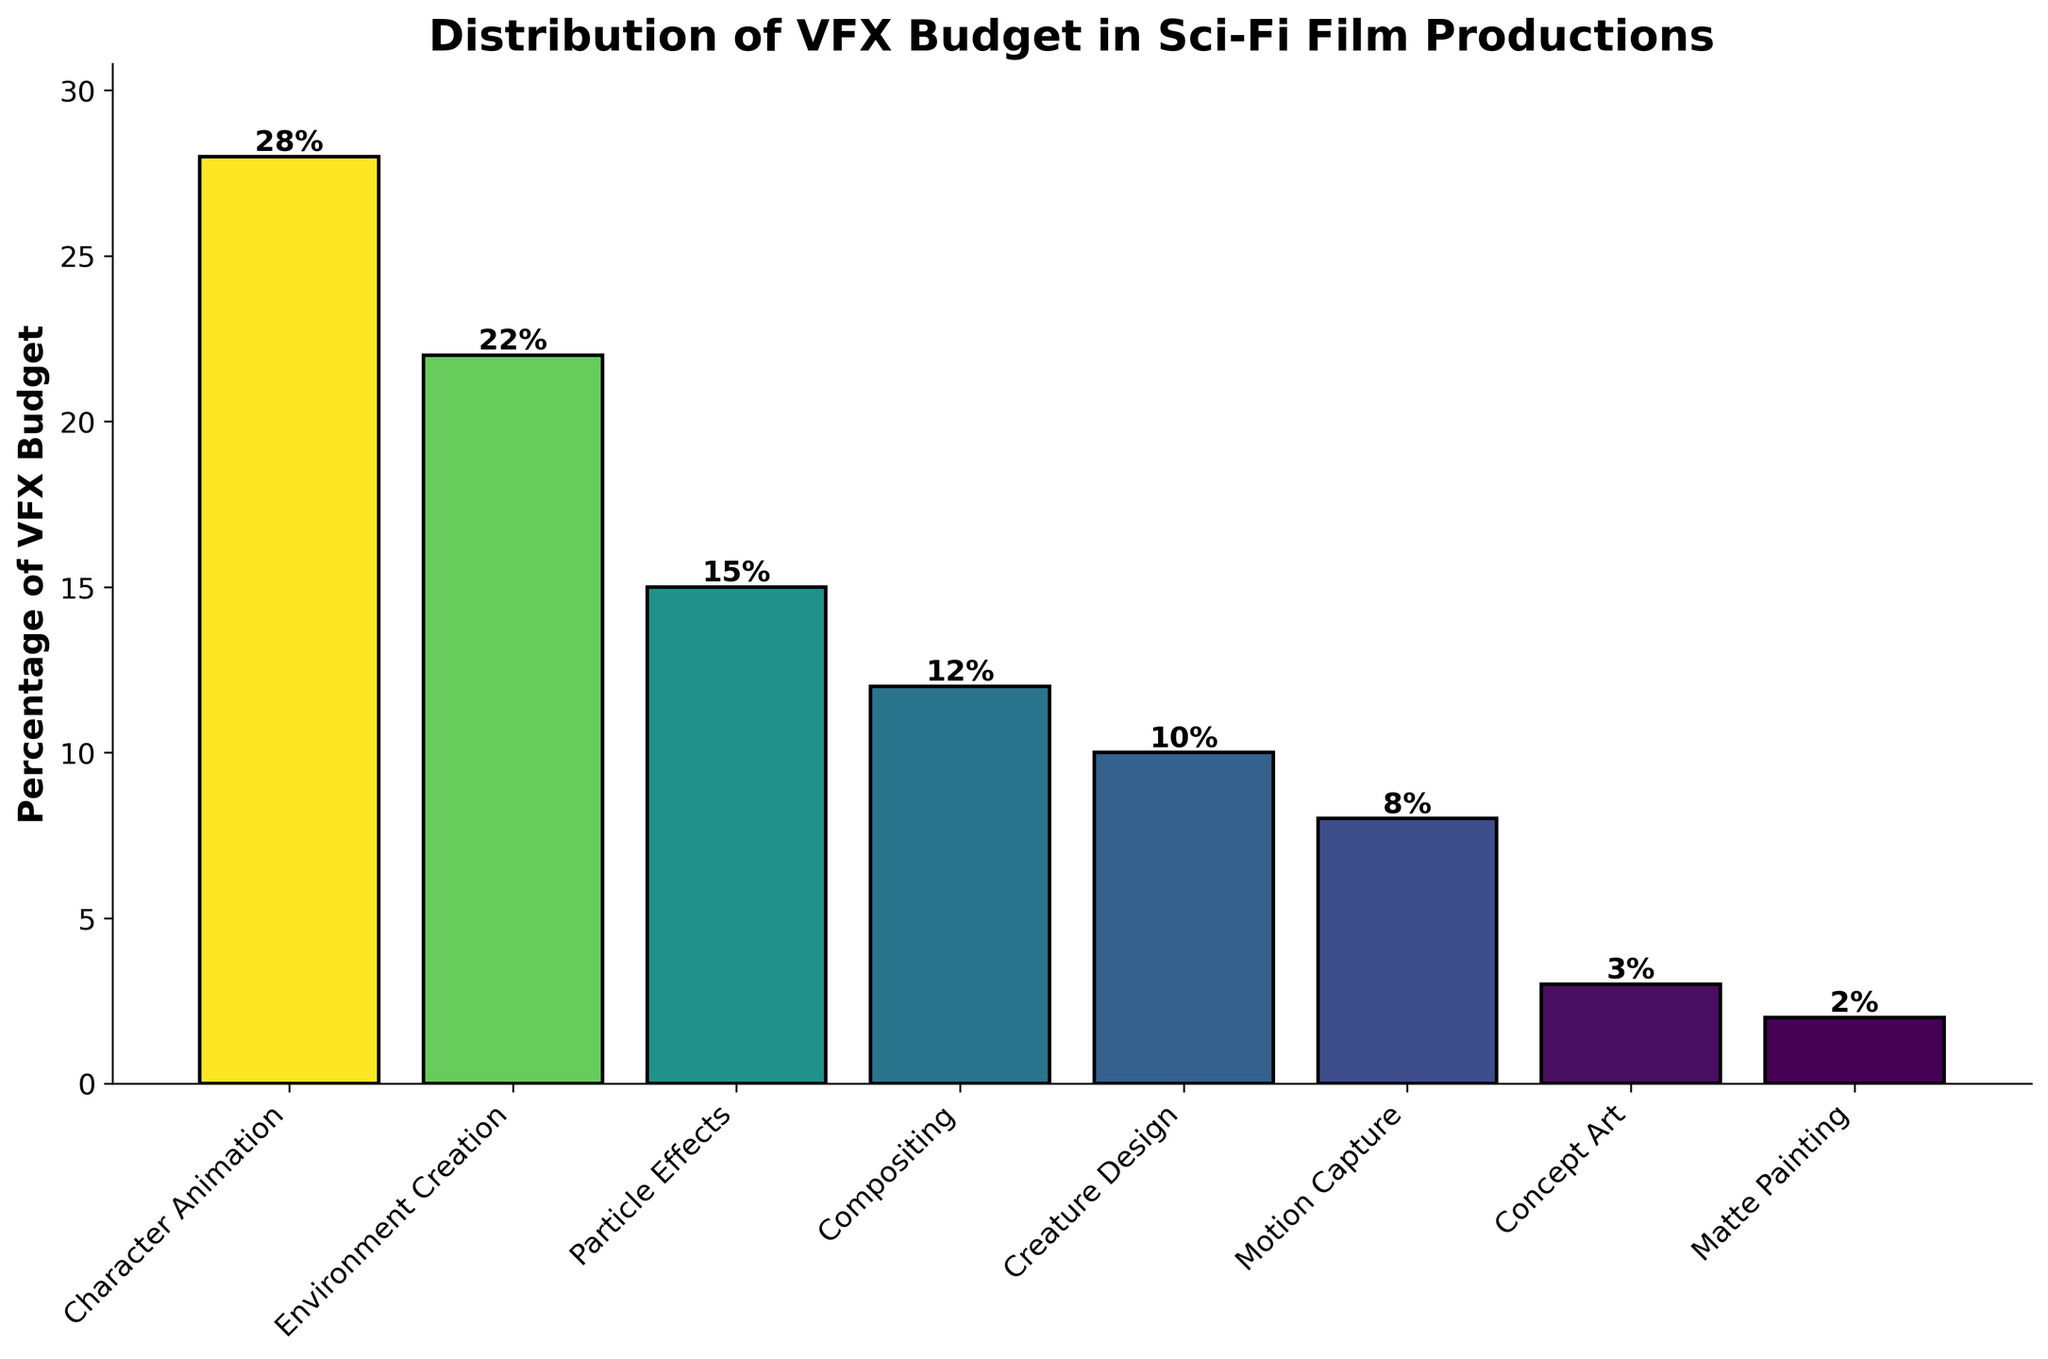Which department has the highest percentage of the VFX budget? The department with the highest bar represents the highest percentage. In the chart, the tallest bar corresponds to "Character Animation" with 28%.
Answer: Character Animation What is the combined percentage of the budget for Particle Effects and Creature Design? Add the percentages for Particle Effects and Creature Design. Particle Effects has 15% and Creature Design has 10%, so 15% + 10% = 25%.
Answer: 25% Which department has a smaller budget percentage, Motion Capture or Compositing? Compare the heights of the bars for Motion Capture and Compositing. The bar for Compositing (12%) is taller than that for Motion Capture (8%).
Answer: Motion Capture How much more budget percentage does Character Animation have compared to Concept Art? Subtract the percentage of Concept Art from Character Animation. Character Animation has 28% and Concept Art has 3%, so 28% - 3% = 25%.
Answer: 25% What is the difference in budget allocation between Environment Creation and Matte Painting? Subtract the percentage of Matte Painting from Environment Creation. Environment Creation has 22% and Matte Painting has 2%, so 22% - 2% = 20%.
Answer: 20% What is the total budget percentage for departments with a budget allocation of 10% or higher? Sum the percentages for all departments with 10% or higher. These are Character Animation (28%), Environment Creation (22%), Particle Effects (15%), and Creature Design (10%). So, 28% + 22% + 15% + 10% = 75%.
Answer: 75% Which color represents the department with the lowest budget percentage? In the color gradient used, the lightest color often represents the lowest percentage. The bar with 2% (Matte Painting) shows the lightest color.
Answer: The lightest color What is the average budget percentage of all departments? Sum all the percentages and divide by the number of departments. (28 + 22 + 15 + 12 + 10 + 8 + 3 + 2) / 8 = 12.5%.
Answer: 12.5% 